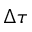<formula> <loc_0><loc_0><loc_500><loc_500>\Delta \tau</formula> 